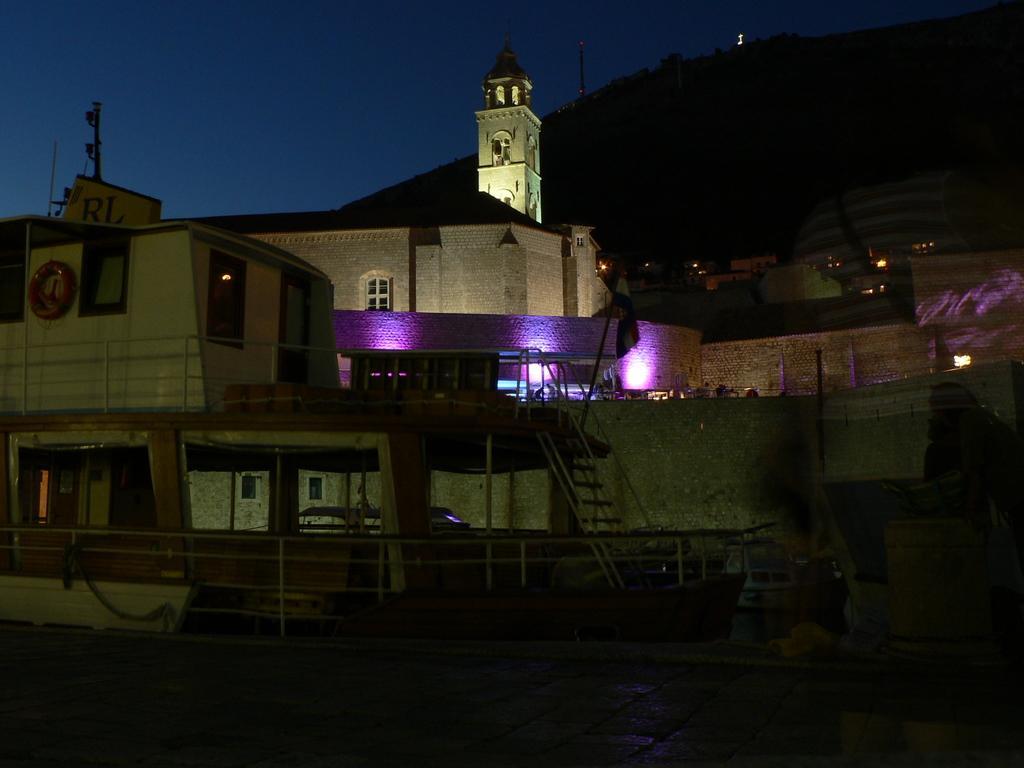Please provide a concise description of this image. In this image we can see there are few ships on the water. In the background there are buildings, mountains and sky. 